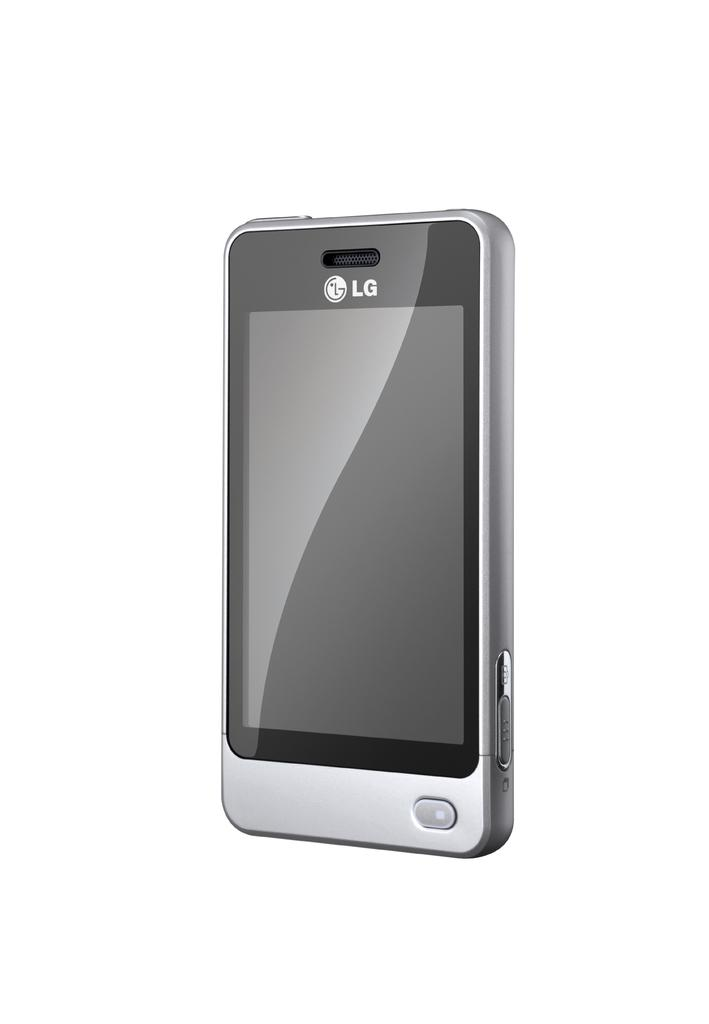<image>
Present a compact description of the photo's key features. An LG smartphone is displayed surrounded by a white background. 